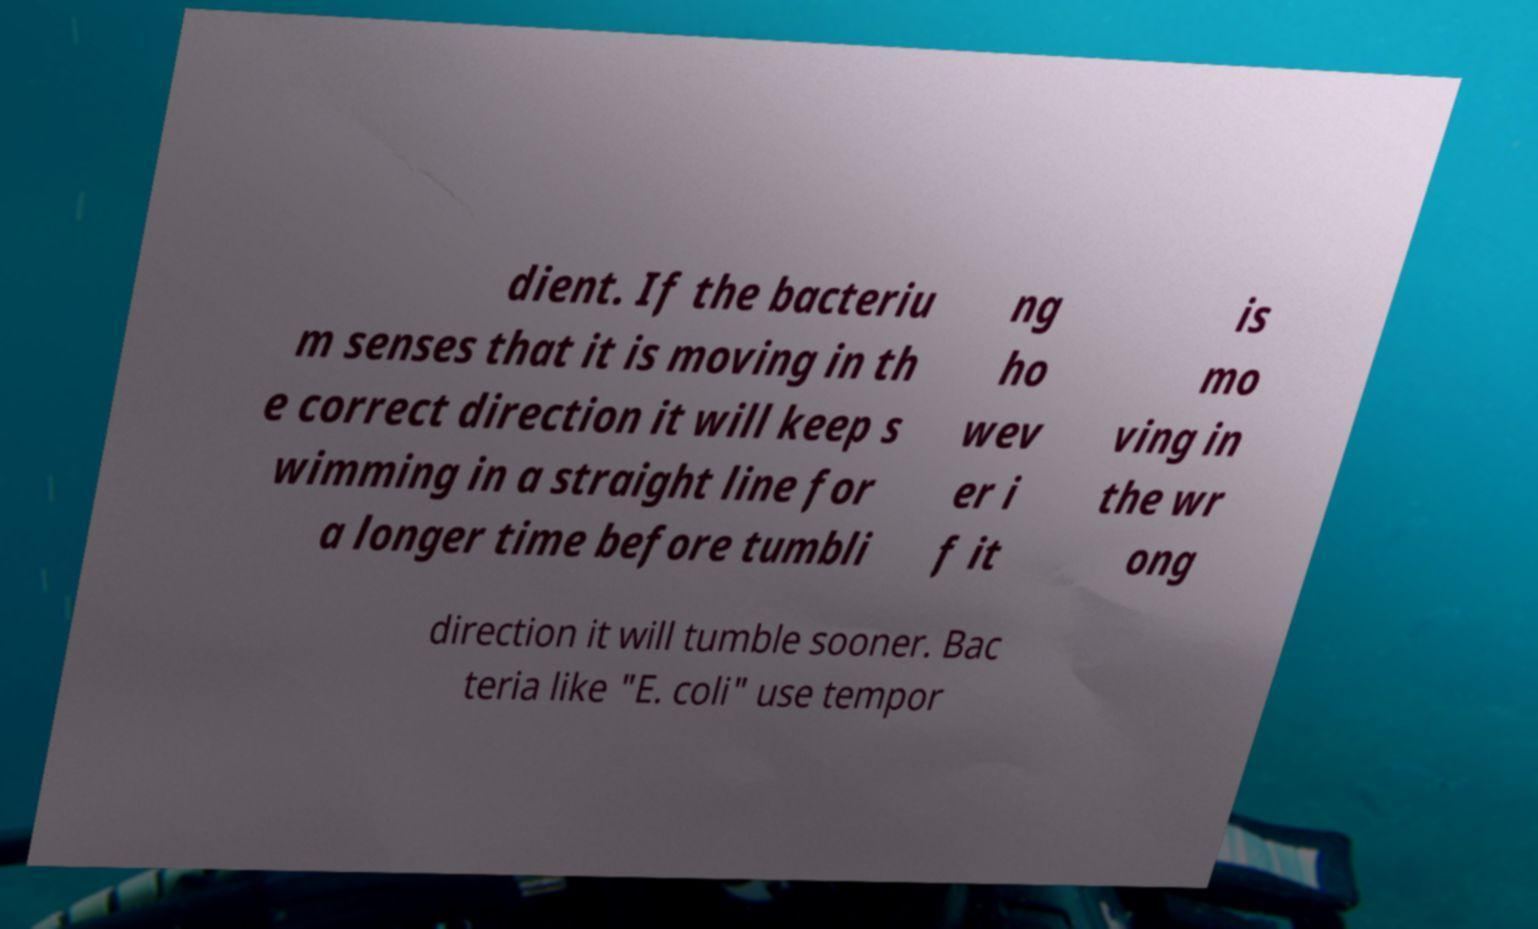I need the written content from this picture converted into text. Can you do that? dient. If the bacteriu m senses that it is moving in th e correct direction it will keep s wimming in a straight line for a longer time before tumbli ng ho wev er i f it is mo ving in the wr ong direction it will tumble sooner. Bac teria like "E. coli" use tempor 